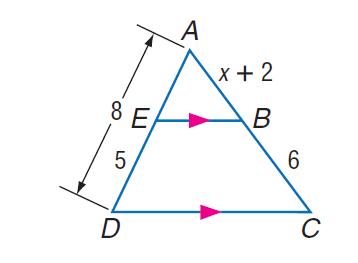Answer the mathemtical geometry problem and directly provide the correct option letter.
Question: Find A C.
Choices: A: 7.6 B: 7.8 C: 9.6 D: 11 C 